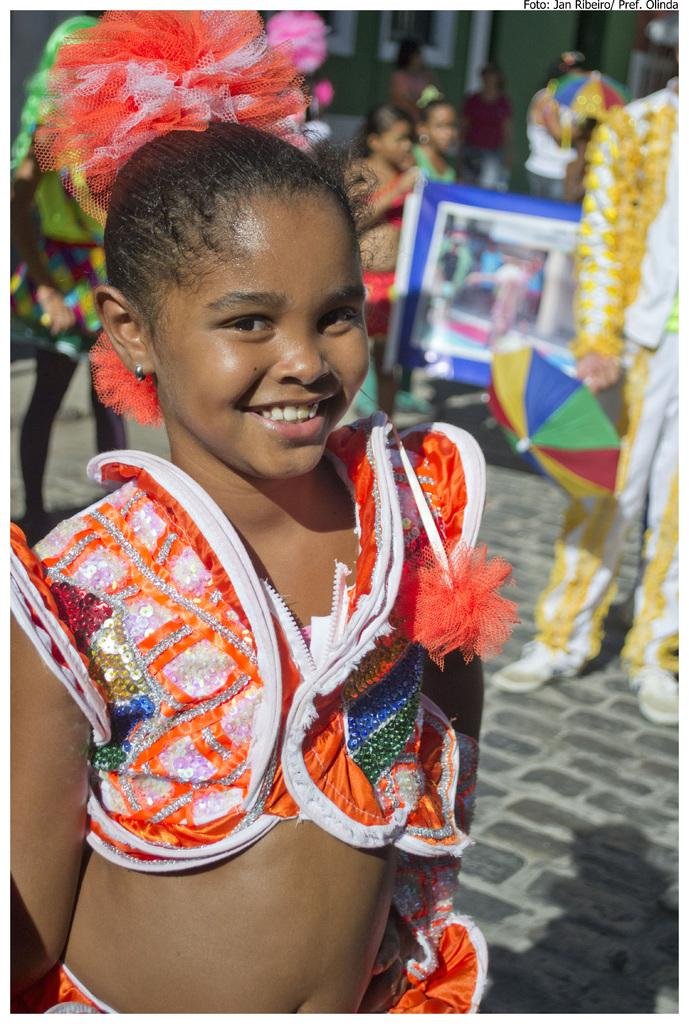Who is the main subject in the image? There is a girl in the image. What is the girl wearing? The girl is wearing an orange dress. Can you describe the background of the image? There are people in the background of the image. Is the girl a spy in the image? There is no indication in the image that the girl is a spy. Does the existence of the girl prove the existence of life? This question is unrelated to the image and does not have a definitive answer based on the provided facts. 